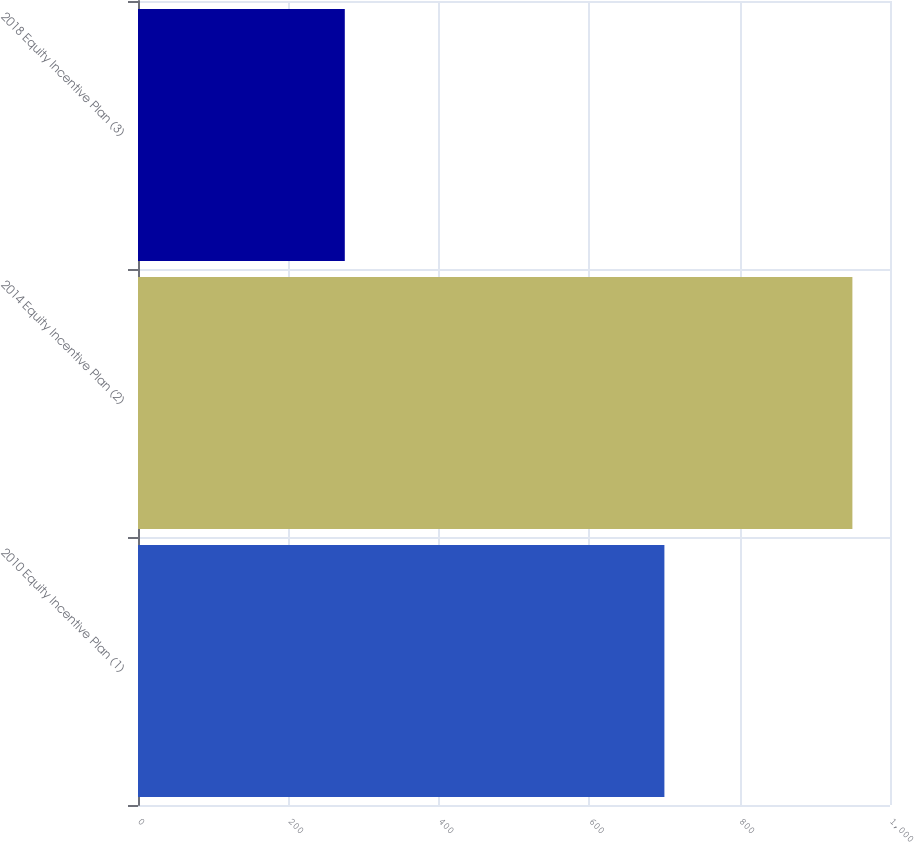Convert chart to OTSL. <chart><loc_0><loc_0><loc_500><loc_500><bar_chart><fcel>2010 Equity Incentive Plan (1)<fcel>2014 Equity Incentive Plan (2)<fcel>2018 Equity Incentive Plan (3)<nl><fcel>700<fcel>950<fcel>275<nl></chart> 